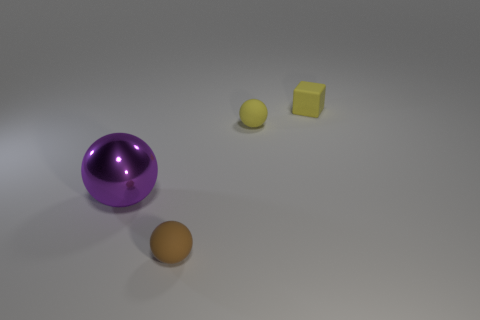What color is the object that is left of the matte sphere in front of the small yellow thing left of the yellow cube?
Make the answer very short. Purple. How many other things are there of the same size as the purple metallic ball?
Provide a short and direct response. 0. Is there anything else that is the same shape as the brown rubber thing?
Ensure brevity in your answer.  Yes. The big thing that is the same shape as the small brown thing is what color?
Provide a short and direct response. Purple. There is another sphere that is made of the same material as the brown ball; what is its color?
Your response must be concise. Yellow. Are there the same number of tiny rubber spheres that are behind the small brown rubber object and yellow rubber objects?
Give a very brief answer. No. There is a sphere that is in front of the purple metallic object; is its size the same as the tiny yellow block?
Your answer should be compact. Yes. What is the color of the matte block that is the same size as the brown rubber thing?
Provide a succinct answer. Yellow. Are there any tiny yellow rubber cubes to the left of the rubber sphere behind the rubber object to the left of the tiny yellow matte sphere?
Your response must be concise. No. There is a small sphere that is to the left of the yellow ball; what is its material?
Make the answer very short. Rubber. 